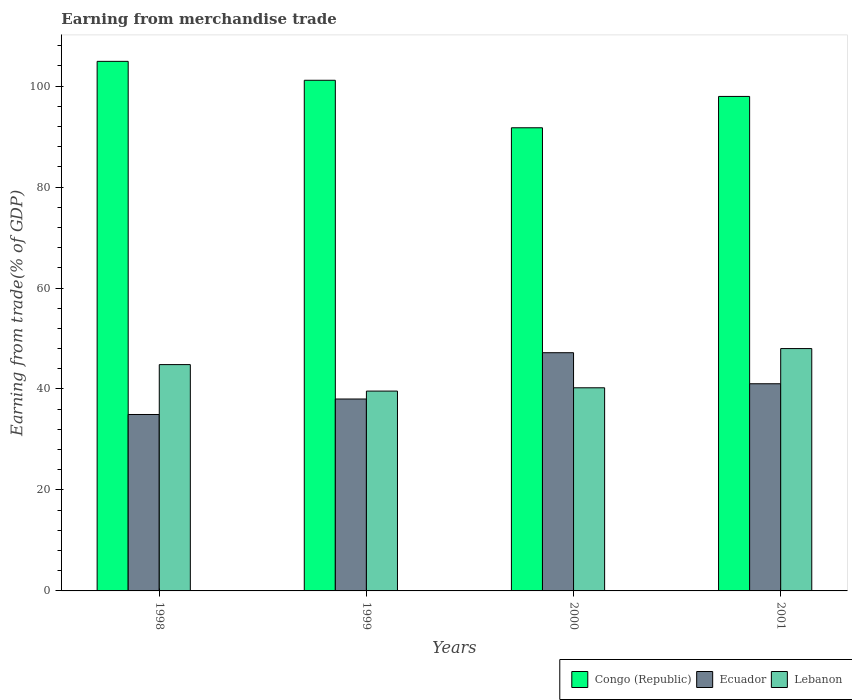How many different coloured bars are there?
Offer a very short reply. 3. How many groups of bars are there?
Ensure brevity in your answer.  4. Are the number of bars on each tick of the X-axis equal?
Give a very brief answer. Yes. How many bars are there on the 2nd tick from the left?
Your response must be concise. 3. How many bars are there on the 3rd tick from the right?
Provide a short and direct response. 3. In how many cases, is the number of bars for a given year not equal to the number of legend labels?
Offer a very short reply. 0. What is the earnings from trade in Congo (Republic) in 1999?
Keep it short and to the point. 101.15. Across all years, what is the maximum earnings from trade in Ecuador?
Give a very brief answer. 47.19. Across all years, what is the minimum earnings from trade in Congo (Republic)?
Offer a very short reply. 91.74. In which year was the earnings from trade in Lebanon minimum?
Make the answer very short. 1999. What is the total earnings from trade in Congo (Republic) in the graph?
Your answer should be very brief. 395.74. What is the difference between the earnings from trade in Congo (Republic) in 1998 and that in 1999?
Make the answer very short. 3.75. What is the difference between the earnings from trade in Ecuador in 2000 and the earnings from trade in Lebanon in 2001?
Provide a succinct answer. -0.82. What is the average earnings from trade in Ecuador per year?
Make the answer very short. 40.3. In the year 2001, what is the difference between the earnings from trade in Ecuador and earnings from trade in Congo (Republic)?
Provide a short and direct response. -56.91. In how many years, is the earnings from trade in Ecuador greater than 80 %?
Make the answer very short. 0. What is the ratio of the earnings from trade in Congo (Republic) in 1999 to that in 2001?
Your answer should be very brief. 1.03. Is the difference between the earnings from trade in Ecuador in 1999 and 2000 greater than the difference between the earnings from trade in Congo (Republic) in 1999 and 2000?
Make the answer very short. No. What is the difference between the highest and the second highest earnings from trade in Congo (Republic)?
Offer a very short reply. 3.75. What is the difference between the highest and the lowest earnings from trade in Lebanon?
Give a very brief answer. 8.42. Is the sum of the earnings from trade in Lebanon in 1999 and 2000 greater than the maximum earnings from trade in Congo (Republic) across all years?
Your answer should be very brief. No. What does the 2nd bar from the left in 1999 represents?
Your response must be concise. Ecuador. What does the 2nd bar from the right in 2000 represents?
Ensure brevity in your answer.  Ecuador. Is it the case that in every year, the sum of the earnings from trade in Congo (Republic) and earnings from trade in Ecuador is greater than the earnings from trade in Lebanon?
Give a very brief answer. Yes. Are the values on the major ticks of Y-axis written in scientific E-notation?
Provide a short and direct response. No. Does the graph contain grids?
Your answer should be compact. No. How are the legend labels stacked?
Offer a terse response. Horizontal. What is the title of the graph?
Give a very brief answer. Earning from merchandise trade. What is the label or title of the X-axis?
Give a very brief answer. Years. What is the label or title of the Y-axis?
Your answer should be very brief. Earning from trade(% of GDP). What is the Earning from trade(% of GDP) in Congo (Republic) in 1998?
Offer a terse response. 104.9. What is the Earning from trade(% of GDP) of Ecuador in 1998?
Make the answer very short. 34.95. What is the Earning from trade(% of GDP) in Lebanon in 1998?
Offer a very short reply. 44.83. What is the Earning from trade(% of GDP) in Congo (Republic) in 1999?
Make the answer very short. 101.15. What is the Earning from trade(% of GDP) of Ecuador in 1999?
Your answer should be very brief. 38.01. What is the Earning from trade(% of GDP) of Lebanon in 1999?
Provide a succinct answer. 39.58. What is the Earning from trade(% of GDP) of Congo (Republic) in 2000?
Offer a terse response. 91.74. What is the Earning from trade(% of GDP) of Ecuador in 2000?
Your answer should be very brief. 47.19. What is the Earning from trade(% of GDP) in Lebanon in 2000?
Your response must be concise. 40.24. What is the Earning from trade(% of GDP) of Congo (Republic) in 2001?
Your answer should be compact. 97.95. What is the Earning from trade(% of GDP) of Ecuador in 2001?
Provide a succinct answer. 41.04. What is the Earning from trade(% of GDP) of Lebanon in 2001?
Ensure brevity in your answer.  48.01. Across all years, what is the maximum Earning from trade(% of GDP) in Congo (Republic)?
Keep it short and to the point. 104.9. Across all years, what is the maximum Earning from trade(% of GDP) in Ecuador?
Keep it short and to the point. 47.19. Across all years, what is the maximum Earning from trade(% of GDP) of Lebanon?
Your answer should be very brief. 48.01. Across all years, what is the minimum Earning from trade(% of GDP) in Congo (Republic)?
Make the answer very short. 91.74. Across all years, what is the minimum Earning from trade(% of GDP) in Ecuador?
Make the answer very short. 34.95. Across all years, what is the minimum Earning from trade(% of GDP) of Lebanon?
Offer a very short reply. 39.58. What is the total Earning from trade(% of GDP) in Congo (Republic) in the graph?
Provide a short and direct response. 395.74. What is the total Earning from trade(% of GDP) in Ecuador in the graph?
Your response must be concise. 161.18. What is the total Earning from trade(% of GDP) of Lebanon in the graph?
Your answer should be very brief. 172.66. What is the difference between the Earning from trade(% of GDP) in Congo (Republic) in 1998 and that in 1999?
Offer a terse response. 3.75. What is the difference between the Earning from trade(% of GDP) of Ecuador in 1998 and that in 1999?
Make the answer very short. -3.07. What is the difference between the Earning from trade(% of GDP) in Lebanon in 1998 and that in 1999?
Provide a short and direct response. 5.25. What is the difference between the Earning from trade(% of GDP) of Congo (Republic) in 1998 and that in 2000?
Your answer should be very brief. 13.16. What is the difference between the Earning from trade(% of GDP) of Ecuador in 1998 and that in 2000?
Give a very brief answer. -12.24. What is the difference between the Earning from trade(% of GDP) in Lebanon in 1998 and that in 2000?
Keep it short and to the point. 4.59. What is the difference between the Earning from trade(% of GDP) of Congo (Republic) in 1998 and that in 2001?
Keep it short and to the point. 6.95. What is the difference between the Earning from trade(% of GDP) in Ecuador in 1998 and that in 2001?
Offer a terse response. -6.09. What is the difference between the Earning from trade(% of GDP) of Lebanon in 1998 and that in 2001?
Provide a succinct answer. -3.18. What is the difference between the Earning from trade(% of GDP) in Congo (Republic) in 1999 and that in 2000?
Your answer should be very brief. 9.41. What is the difference between the Earning from trade(% of GDP) in Ecuador in 1999 and that in 2000?
Provide a short and direct response. -9.17. What is the difference between the Earning from trade(% of GDP) in Lebanon in 1999 and that in 2000?
Offer a very short reply. -0.65. What is the difference between the Earning from trade(% of GDP) in Congo (Republic) in 1999 and that in 2001?
Give a very brief answer. 3.2. What is the difference between the Earning from trade(% of GDP) of Ecuador in 1999 and that in 2001?
Give a very brief answer. -3.02. What is the difference between the Earning from trade(% of GDP) in Lebanon in 1999 and that in 2001?
Your answer should be compact. -8.42. What is the difference between the Earning from trade(% of GDP) of Congo (Republic) in 2000 and that in 2001?
Your response must be concise. -6.21. What is the difference between the Earning from trade(% of GDP) in Ecuador in 2000 and that in 2001?
Give a very brief answer. 6.15. What is the difference between the Earning from trade(% of GDP) of Lebanon in 2000 and that in 2001?
Provide a succinct answer. -7.77. What is the difference between the Earning from trade(% of GDP) in Congo (Republic) in 1998 and the Earning from trade(% of GDP) in Ecuador in 1999?
Provide a succinct answer. 66.89. What is the difference between the Earning from trade(% of GDP) in Congo (Republic) in 1998 and the Earning from trade(% of GDP) in Lebanon in 1999?
Provide a short and direct response. 65.32. What is the difference between the Earning from trade(% of GDP) of Ecuador in 1998 and the Earning from trade(% of GDP) of Lebanon in 1999?
Your answer should be very brief. -4.64. What is the difference between the Earning from trade(% of GDP) of Congo (Republic) in 1998 and the Earning from trade(% of GDP) of Ecuador in 2000?
Give a very brief answer. 57.71. What is the difference between the Earning from trade(% of GDP) in Congo (Republic) in 1998 and the Earning from trade(% of GDP) in Lebanon in 2000?
Provide a succinct answer. 64.66. What is the difference between the Earning from trade(% of GDP) in Ecuador in 1998 and the Earning from trade(% of GDP) in Lebanon in 2000?
Your answer should be compact. -5.29. What is the difference between the Earning from trade(% of GDP) in Congo (Republic) in 1998 and the Earning from trade(% of GDP) in Ecuador in 2001?
Your answer should be compact. 63.86. What is the difference between the Earning from trade(% of GDP) of Congo (Republic) in 1998 and the Earning from trade(% of GDP) of Lebanon in 2001?
Your answer should be compact. 56.89. What is the difference between the Earning from trade(% of GDP) of Ecuador in 1998 and the Earning from trade(% of GDP) of Lebanon in 2001?
Offer a terse response. -13.06. What is the difference between the Earning from trade(% of GDP) of Congo (Republic) in 1999 and the Earning from trade(% of GDP) of Ecuador in 2000?
Your answer should be very brief. 53.97. What is the difference between the Earning from trade(% of GDP) of Congo (Republic) in 1999 and the Earning from trade(% of GDP) of Lebanon in 2000?
Provide a succinct answer. 60.91. What is the difference between the Earning from trade(% of GDP) in Ecuador in 1999 and the Earning from trade(% of GDP) in Lebanon in 2000?
Your answer should be compact. -2.22. What is the difference between the Earning from trade(% of GDP) of Congo (Republic) in 1999 and the Earning from trade(% of GDP) of Ecuador in 2001?
Provide a short and direct response. 60.11. What is the difference between the Earning from trade(% of GDP) in Congo (Republic) in 1999 and the Earning from trade(% of GDP) in Lebanon in 2001?
Ensure brevity in your answer.  53.14. What is the difference between the Earning from trade(% of GDP) in Ecuador in 1999 and the Earning from trade(% of GDP) in Lebanon in 2001?
Make the answer very short. -9.99. What is the difference between the Earning from trade(% of GDP) of Congo (Republic) in 2000 and the Earning from trade(% of GDP) of Ecuador in 2001?
Your response must be concise. 50.7. What is the difference between the Earning from trade(% of GDP) in Congo (Republic) in 2000 and the Earning from trade(% of GDP) in Lebanon in 2001?
Offer a terse response. 43.74. What is the difference between the Earning from trade(% of GDP) in Ecuador in 2000 and the Earning from trade(% of GDP) in Lebanon in 2001?
Provide a short and direct response. -0.82. What is the average Earning from trade(% of GDP) of Congo (Republic) per year?
Give a very brief answer. 98.94. What is the average Earning from trade(% of GDP) of Ecuador per year?
Your answer should be compact. 40.3. What is the average Earning from trade(% of GDP) of Lebanon per year?
Offer a very short reply. 43.16. In the year 1998, what is the difference between the Earning from trade(% of GDP) in Congo (Republic) and Earning from trade(% of GDP) in Ecuador?
Your answer should be compact. 69.95. In the year 1998, what is the difference between the Earning from trade(% of GDP) of Congo (Republic) and Earning from trade(% of GDP) of Lebanon?
Ensure brevity in your answer.  60.07. In the year 1998, what is the difference between the Earning from trade(% of GDP) of Ecuador and Earning from trade(% of GDP) of Lebanon?
Provide a short and direct response. -9.88. In the year 1999, what is the difference between the Earning from trade(% of GDP) in Congo (Republic) and Earning from trade(% of GDP) in Ecuador?
Your answer should be very brief. 63.14. In the year 1999, what is the difference between the Earning from trade(% of GDP) in Congo (Republic) and Earning from trade(% of GDP) in Lebanon?
Make the answer very short. 61.57. In the year 1999, what is the difference between the Earning from trade(% of GDP) in Ecuador and Earning from trade(% of GDP) in Lebanon?
Provide a short and direct response. -1.57. In the year 2000, what is the difference between the Earning from trade(% of GDP) of Congo (Republic) and Earning from trade(% of GDP) of Ecuador?
Give a very brief answer. 44.56. In the year 2000, what is the difference between the Earning from trade(% of GDP) in Congo (Republic) and Earning from trade(% of GDP) in Lebanon?
Provide a succinct answer. 51.51. In the year 2000, what is the difference between the Earning from trade(% of GDP) in Ecuador and Earning from trade(% of GDP) in Lebanon?
Give a very brief answer. 6.95. In the year 2001, what is the difference between the Earning from trade(% of GDP) of Congo (Republic) and Earning from trade(% of GDP) of Ecuador?
Make the answer very short. 56.91. In the year 2001, what is the difference between the Earning from trade(% of GDP) of Congo (Republic) and Earning from trade(% of GDP) of Lebanon?
Offer a terse response. 49.94. In the year 2001, what is the difference between the Earning from trade(% of GDP) in Ecuador and Earning from trade(% of GDP) in Lebanon?
Provide a short and direct response. -6.97. What is the ratio of the Earning from trade(% of GDP) in Congo (Republic) in 1998 to that in 1999?
Provide a succinct answer. 1.04. What is the ratio of the Earning from trade(% of GDP) in Ecuador in 1998 to that in 1999?
Your response must be concise. 0.92. What is the ratio of the Earning from trade(% of GDP) in Lebanon in 1998 to that in 1999?
Offer a very short reply. 1.13. What is the ratio of the Earning from trade(% of GDP) in Congo (Republic) in 1998 to that in 2000?
Give a very brief answer. 1.14. What is the ratio of the Earning from trade(% of GDP) in Ecuador in 1998 to that in 2000?
Your answer should be compact. 0.74. What is the ratio of the Earning from trade(% of GDP) of Lebanon in 1998 to that in 2000?
Your response must be concise. 1.11. What is the ratio of the Earning from trade(% of GDP) of Congo (Republic) in 1998 to that in 2001?
Give a very brief answer. 1.07. What is the ratio of the Earning from trade(% of GDP) of Ecuador in 1998 to that in 2001?
Your answer should be very brief. 0.85. What is the ratio of the Earning from trade(% of GDP) of Lebanon in 1998 to that in 2001?
Give a very brief answer. 0.93. What is the ratio of the Earning from trade(% of GDP) of Congo (Republic) in 1999 to that in 2000?
Your answer should be very brief. 1.1. What is the ratio of the Earning from trade(% of GDP) in Ecuador in 1999 to that in 2000?
Provide a succinct answer. 0.81. What is the ratio of the Earning from trade(% of GDP) in Lebanon in 1999 to that in 2000?
Give a very brief answer. 0.98. What is the ratio of the Earning from trade(% of GDP) of Congo (Republic) in 1999 to that in 2001?
Give a very brief answer. 1.03. What is the ratio of the Earning from trade(% of GDP) of Ecuador in 1999 to that in 2001?
Your answer should be compact. 0.93. What is the ratio of the Earning from trade(% of GDP) in Lebanon in 1999 to that in 2001?
Provide a succinct answer. 0.82. What is the ratio of the Earning from trade(% of GDP) in Congo (Republic) in 2000 to that in 2001?
Your answer should be compact. 0.94. What is the ratio of the Earning from trade(% of GDP) of Ecuador in 2000 to that in 2001?
Offer a terse response. 1.15. What is the ratio of the Earning from trade(% of GDP) of Lebanon in 2000 to that in 2001?
Provide a short and direct response. 0.84. What is the difference between the highest and the second highest Earning from trade(% of GDP) of Congo (Republic)?
Your answer should be compact. 3.75. What is the difference between the highest and the second highest Earning from trade(% of GDP) of Ecuador?
Your response must be concise. 6.15. What is the difference between the highest and the second highest Earning from trade(% of GDP) of Lebanon?
Ensure brevity in your answer.  3.18. What is the difference between the highest and the lowest Earning from trade(% of GDP) of Congo (Republic)?
Your answer should be very brief. 13.16. What is the difference between the highest and the lowest Earning from trade(% of GDP) in Ecuador?
Keep it short and to the point. 12.24. What is the difference between the highest and the lowest Earning from trade(% of GDP) of Lebanon?
Give a very brief answer. 8.42. 